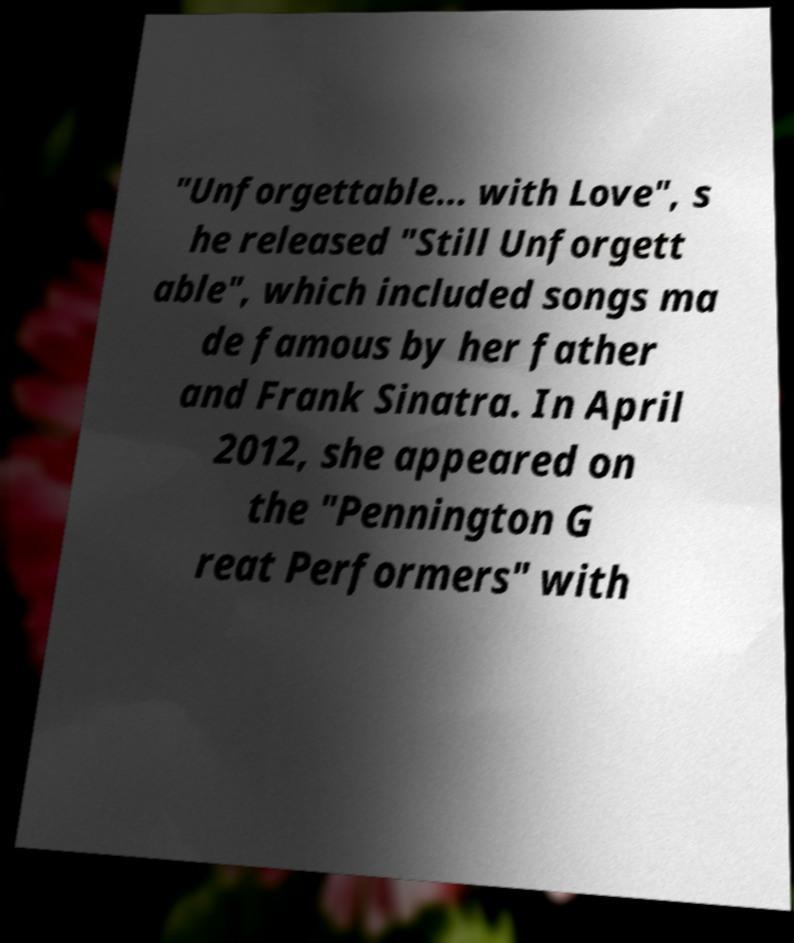Please identify and transcribe the text found in this image. "Unforgettable... with Love", s he released "Still Unforgett able", which included songs ma de famous by her father and Frank Sinatra. In April 2012, she appeared on the "Pennington G reat Performers" with 